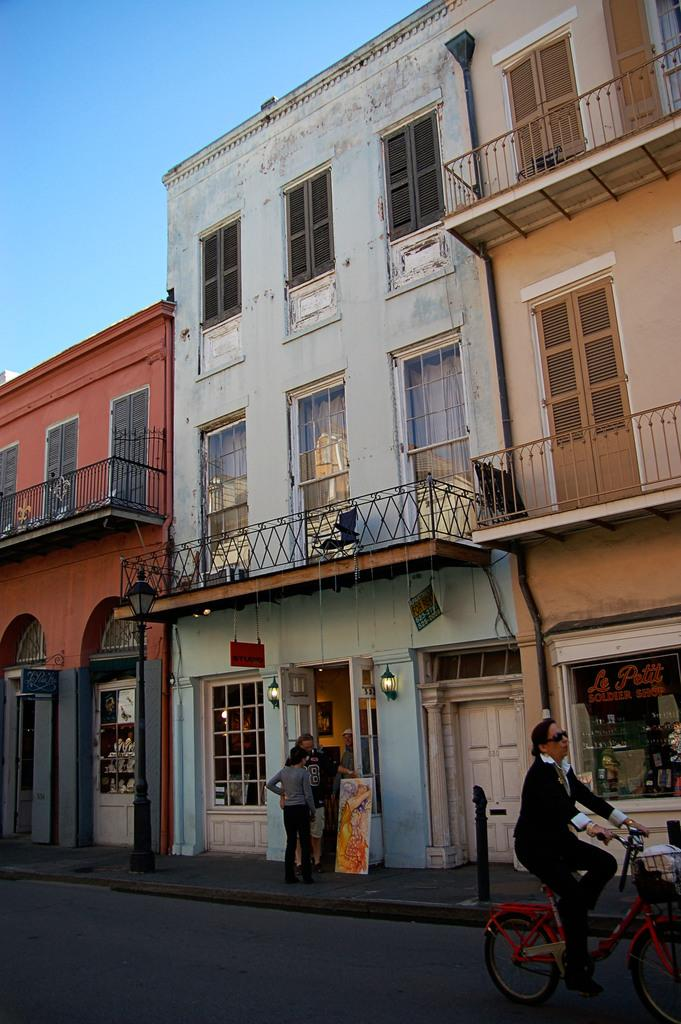What can be seen in the background of the image? There is a sky in the image. What type of structures are present in the image? There are buildings in the image. What is the surface that vehicles might travel on in the image? There is a road in the image. What activity is the woman engaged in? A woman is riding a bicycle in the image. What color is the woman's hair while she is riding the bicycle in the image? There is no information about the color of the woman's hair in the image. Can you see a pear in the woman's hand while she is riding the bicycle in the image? There is no pear present in the image. 